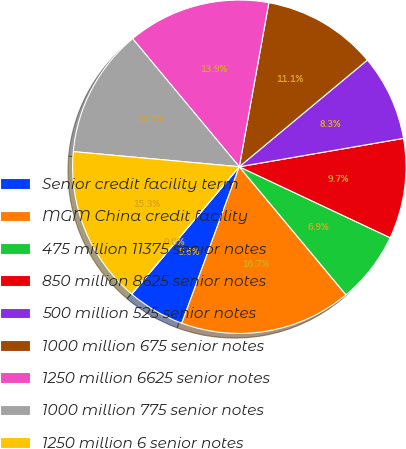Convert chart. <chart><loc_0><loc_0><loc_500><loc_500><pie_chart><fcel>Senior credit facility term<fcel>MGM China credit facility<fcel>475 million 11375 senior notes<fcel>850 million 8625 senior notes<fcel>500 million 525 senior notes<fcel>1000 million 675 senior notes<fcel>1250 million 6625 senior notes<fcel>1000 million 775 senior notes<fcel>1250 million 6 senior notes<fcel>06 million 7 debentures due<nl><fcel>5.56%<fcel>16.66%<fcel>6.95%<fcel>9.72%<fcel>8.33%<fcel>11.11%<fcel>13.89%<fcel>12.5%<fcel>15.28%<fcel>0.0%<nl></chart> 